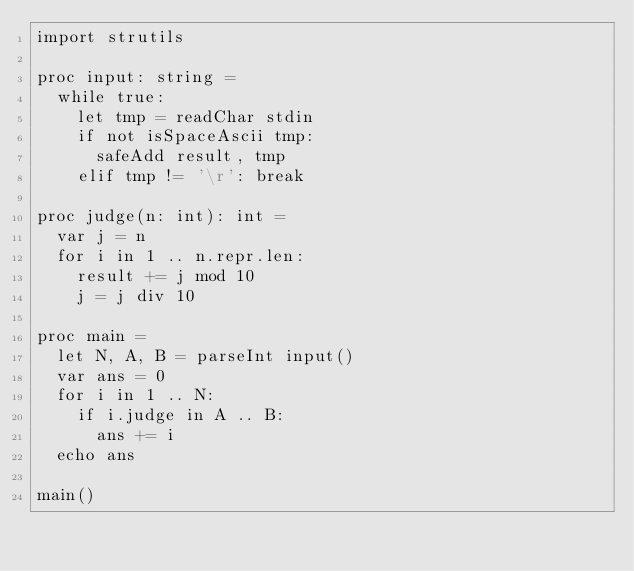<code> <loc_0><loc_0><loc_500><loc_500><_Nim_>import strutils

proc input: string =
  while true:
    let tmp = readChar stdin
    if not isSpaceAscii tmp:
      safeAdd result, tmp
    elif tmp != '\r': break

proc judge(n: int): int =
  var j = n
  for i in 1 .. n.repr.len:
    result += j mod 10
    j = j div 10

proc main =
  let N, A, B = parseInt input()
  var ans = 0
  for i in 1 .. N:
    if i.judge in A .. B:
      ans += i
  echo ans

main()</code> 